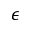<formula> <loc_0><loc_0><loc_500><loc_500>\epsilon</formula> 